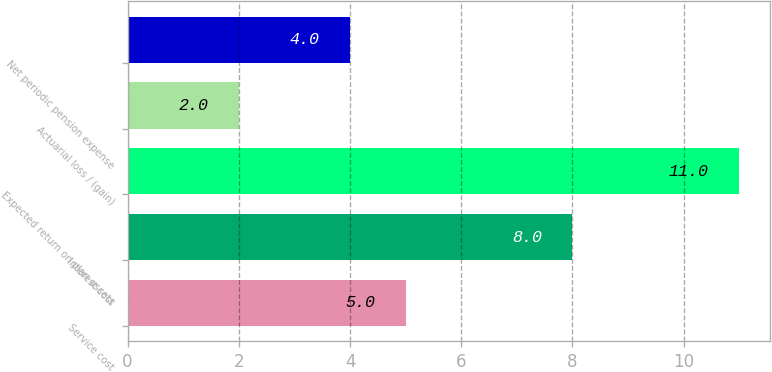<chart> <loc_0><loc_0><loc_500><loc_500><bar_chart><fcel>Service cost<fcel>Interest cost<fcel>Expected return on plan assets<fcel>Actuarial loss / (gain)<fcel>Net periodic pension expense<nl><fcel>5<fcel>8<fcel>11<fcel>2<fcel>4<nl></chart> 